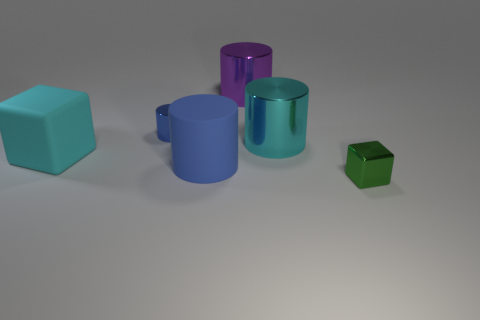Subtract all purple metal cylinders. How many cylinders are left? 3 Add 1 large blocks. How many objects exist? 7 Subtract all purple cylinders. How many cylinders are left? 3 Subtract all cubes. How many objects are left? 4 Subtract all purple blocks. Subtract all cyan cylinders. How many blocks are left? 2 Subtract all blue cubes. How many cyan cylinders are left? 1 Subtract all shiny blocks. Subtract all big rubber things. How many objects are left? 3 Add 2 large cyan cubes. How many large cyan cubes are left? 3 Add 2 large blue matte things. How many large blue matte things exist? 3 Subtract 1 purple cylinders. How many objects are left? 5 